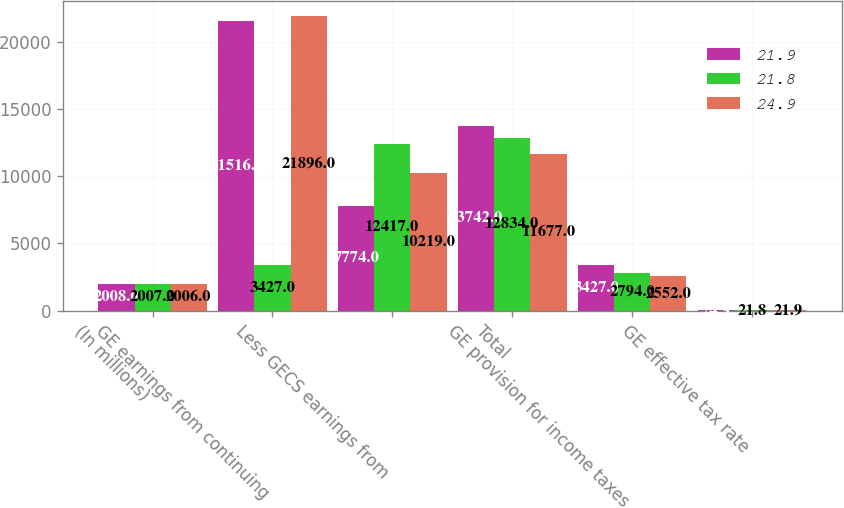Convert chart. <chart><loc_0><loc_0><loc_500><loc_500><stacked_bar_chart><ecel><fcel>(In millions)<fcel>GE earnings from continuing<fcel>Less GECS earnings from<fcel>Total<fcel>GE provision for income taxes<fcel>GE effective tax rate<nl><fcel>21.9<fcel>2008<fcel>21516<fcel>7774<fcel>13742<fcel>3427<fcel>24.9<nl><fcel>21.8<fcel>2007<fcel>3427<fcel>12417<fcel>12834<fcel>2794<fcel>21.8<nl><fcel>24.9<fcel>2006<fcel>21896<fcel>10219<fcel>11677<fcel>2552<fcel>21.9<nl></chart> 